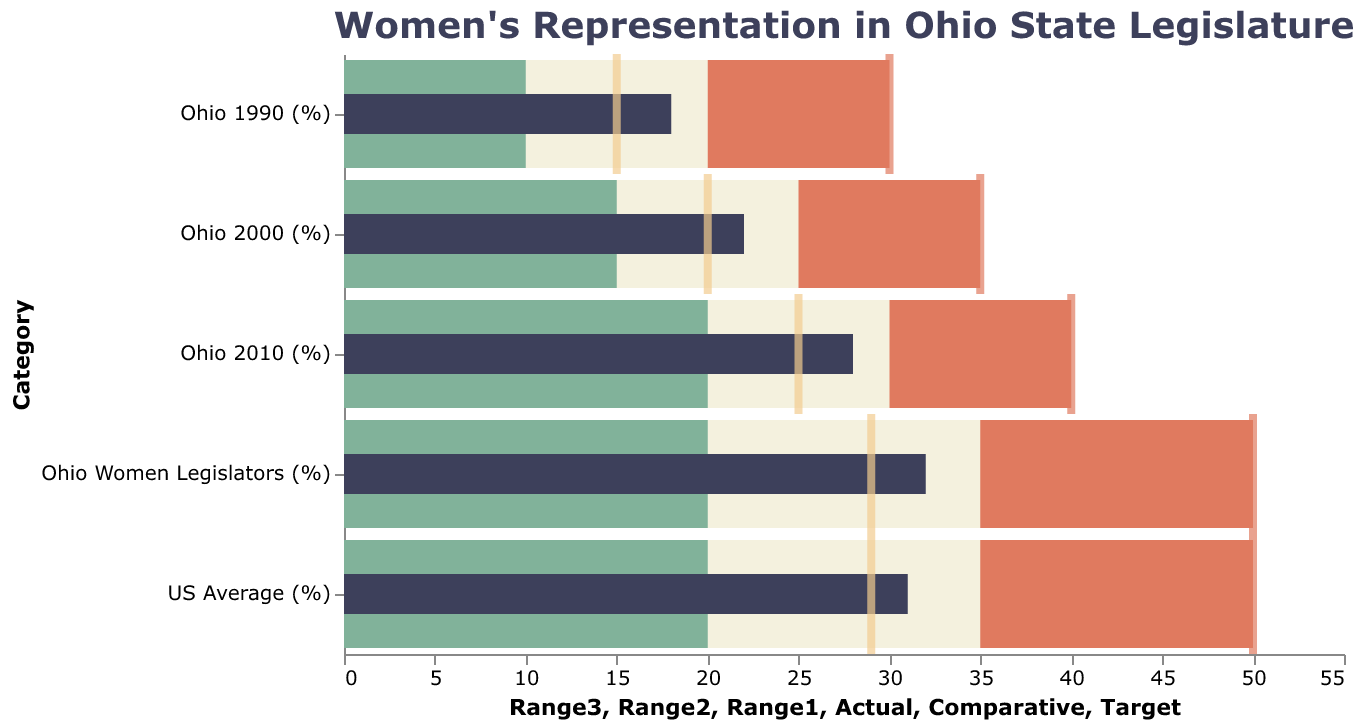What is the actual percentage of women legislators in Ohio? The actual percentage of women legislators in Ohio is represented by the dark bar in the corresponding bullet chart section. According to the data, this value is 32%.
Answer: 32% How does the actual percentage of women legislators in Ohio compare to the US average? Both percentages can be found by looking at the dark bars in the bullet chart. The actual percentage of women legislators in Ohio is 32%, while the US average is 31%. Therefore, Ohio's percentage is 1% higher than the US average.
Answer: Ohio: 32%, US: 31% What is the target percentage of women legislators according to the bullet chart? The target percentage is indicated by the red tick mark in each category. All categories in the chart share a uniform target value of 50%.
Answer: 50% How has women's representation in Ohio's legislature changed from 1990 to 2010? To determine this, we need to compare the actual percentages from 1990, 2000, and 2010 as indicated by the dark bars. In 1990, it was 18%; in 2000, it increased to 22%; and by 2010, it further increased to 28%. This shows a steady upward trend over these years.
Answer: Increased from 18% in 1990 to 28% in 2010 What is the comparative percentage of women legislators for Ohio and how does it compare to the actual value? The comparative percentage for Ohio is represented by the yellow tick in the chart, which is 29%. The actual value is 32%, indicating the actual percentage exceeds the comparative percentage by 3%.
Answer: Comparative: 29%, Actual: 32% What range is represented by the lightest shade of green in the bullet chart? The lightest shade of green (Range1) represents the lowest performance range in the bullet chart, and for each category, this range spans from 0% to 20%.
Answer: 0% to 20% Compare the actual and comparative percentages of women legislators in Ohio in 2010. Which one is higher? The actual percentage for 2010 is indicated by the dark bar and is 28%, while the comparative percentage, shown by the yellow tick, is 25%. Therefore, the actual percentage is higher by 3%.
Answer: Actual: 28%, Comparative: 25% What is the difference between the actual and target percentages of Ohio women legislators? The actual percentage is represented by the dark bar (32%), and the target percentage by the red tick (50%). The difference between these two percentages is 50% - 32% = 18%.
Answer: 18% Is Ohio currently meeting its target for women's representation in the state legislature? The current actual percentage (32%) is compared to the target percentage (50%). Ohio is not meeting its target since the actual percentage is below the target.
Answer: No 